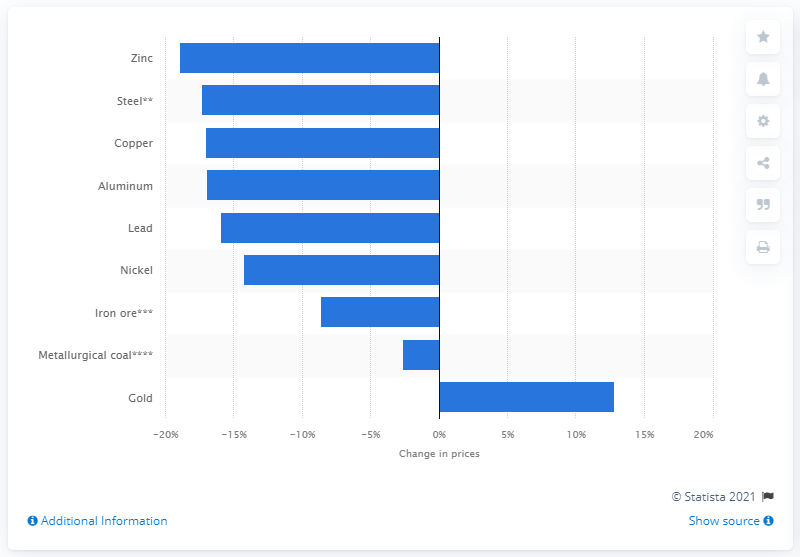Draw attention to some important aspects in this diagram. The price of gold increased by 12.8% during the COVID-19 pandemic. 